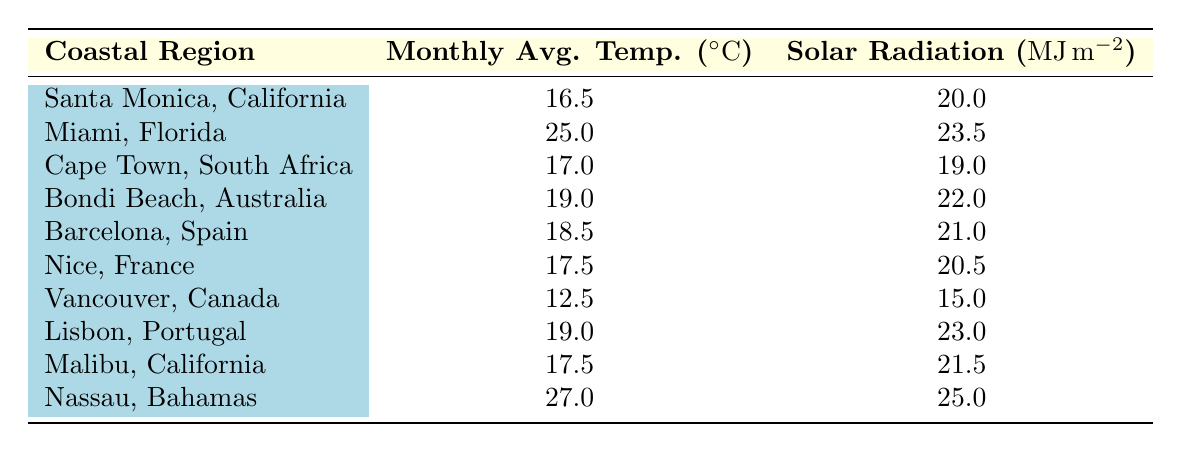What is the solar radiation exposure in Nassau, Bahamas? The table lists that Nassau, Bahamas has a solar radiation exposure of 25.0 MJ/m².
Answer: 25.0 MJ/m² What is the monthly average temperature in Santa Monica, California? The table shows that the monthly average temperature in Santa Monica, California is 16.5°C.
Answer: 16.5°C Which coastal region has the highest solar radiation exposure? By comparing the solar radiation exposure values, Nassau, Bahamas has the highest value of 25.0 MJ/m².
Answer: Nassau, Bahamas Is the average monthly temperature in Vancouver, Canada higher than 15°C? The table indicates the monthly average temperature in Vancouver, Canada is 12.5°C, which is lower than 15°C, therefore the statement is false.
Answer: No What is the difference in monthly average temperature between Miami, Florida, and Cape Town, South Africa? The monthly average temperature in Miami, Florida is 25.0°C and in Cape Town, South Africa it is 17.0°C. The difference is 25.0 - 17.0 = 8.0°C.
Answer: 8.0°C Which coastal region has a solar radiation exposure of 19.0 MJ/m²? The table lists Cape Town, South Africa with a solar radiation exposure of 19.0 MJ/m².
Answer: Cape Town, South Africa Calculate the average solar radiation exposure for the regions listed in the table. To calculate the average, we sum up all the solar radiation exposure values: 20.0 + 23.5 + 19.0 + 22.0 + 21.0 + 20.5 + 15.0 + 23.0 + 21.5 + 25.0 = 210.5 MJ/m². There are 10 regions, so the average is 210.5 / 10 = 21.05 MJ/m².
Answer: 21.05 MJ/m² Is the solar radiation exposure in Nice, France greater than the average solar radiation exposure calculated? The solar radiation exposure in Nice, France is 20.5 MJ/m². The previously calculated average solar radiation exposure is 21.05 MJ/m². Since 20.5 is less than 21.05, the statement is false.
Answer: No Which regions have a monthly average temperature above 18°C? The regions with a monthly average temperature above 18°C are Miami, Florida (25.0°C) and Nassau, Bahamas (27.0°C), listed as the only two.
Answer: Miami, Florida and Nassau, Bahamas 